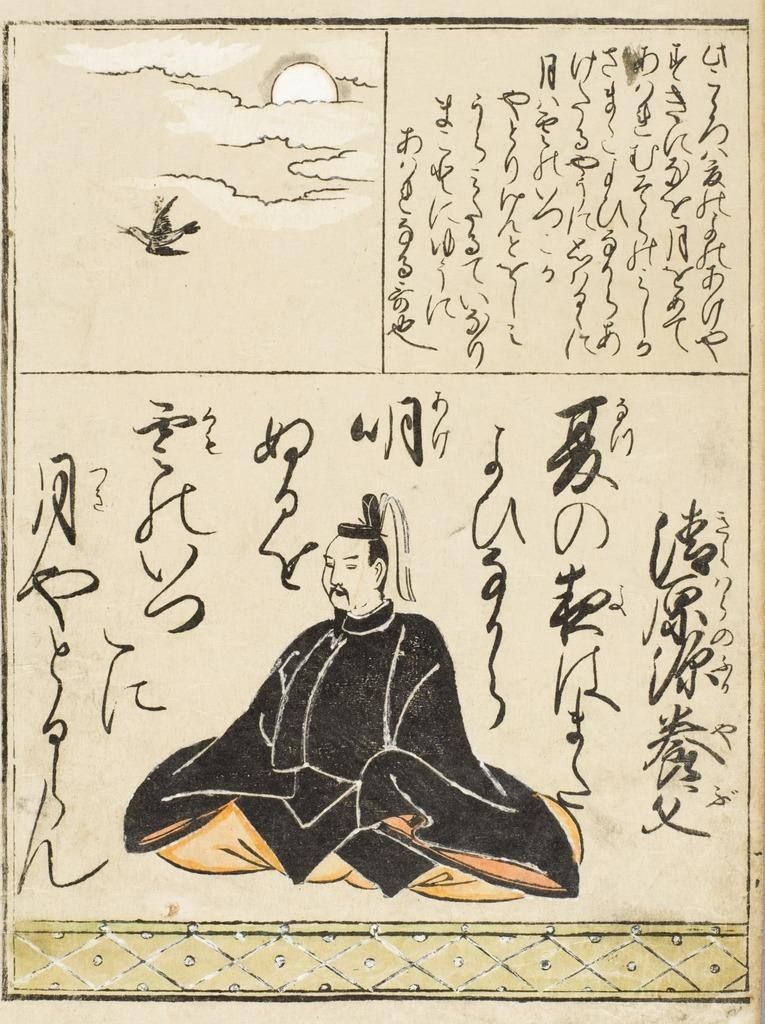What is the main object in the image? There is a paper poster in the image. What is depicted on the poster? The poster depicts a man wearing a black gown. Can you describe the setting in the image? The setting is not explicitly described, but it is likely related to the poster's context. What is written on the poster? There is writing on the top of the poster. How many pies are displayed on the man's face in the image? There are no pies or faces present in the image; it features a paper poster with a man wearing a black gown. What type of payment is accepted for the event mentioned on the poster? The facts provided do not mention any event or payment method, so it cannot be determined from the image. 